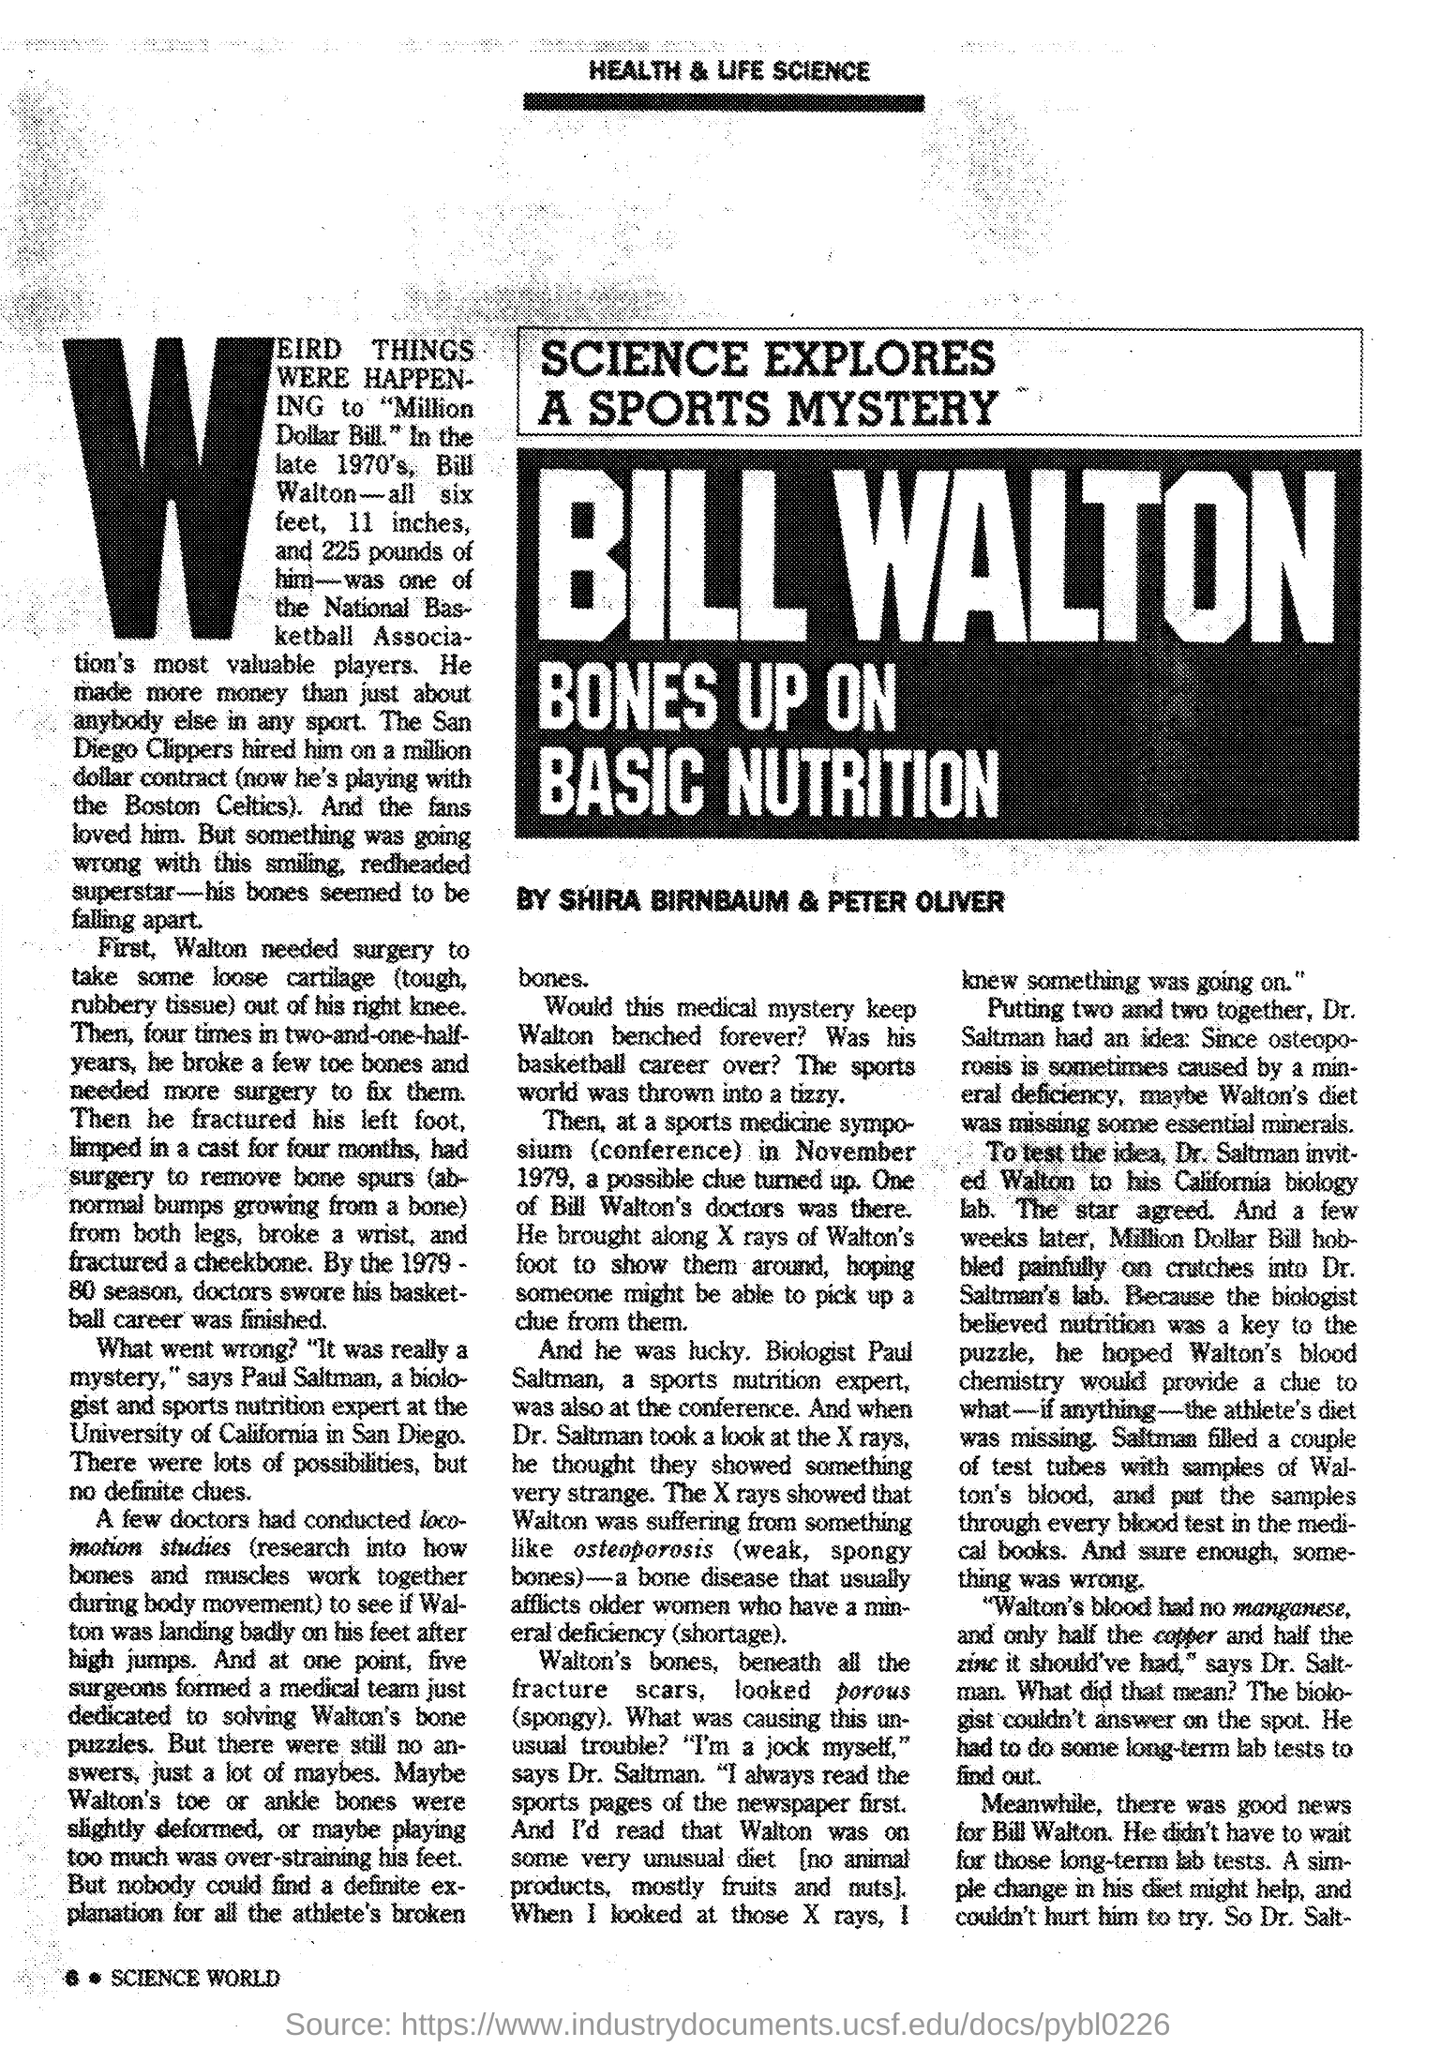What is the Page Number?
Provide a succinct answer. 6. Which person submitted the report?
Your response must be concise. Shira Birnbaum & Peter Oliver. 